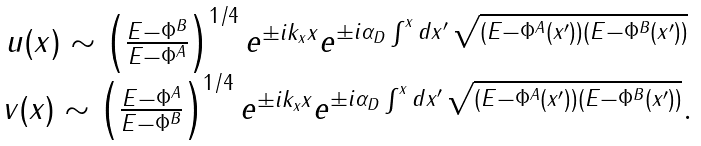<formula> <loc_0><loc_0><loc_500><loc_500>\begin{array} { c } u ( x ) \sim \left ( \frac { E - \Phi ^ { B } } { E - \Phi ^ { A } } \right ) ^ { 1 / 4 } e ^ { \pm i k _ { x } x } e ^ { \pm i \alpha _ { D } \int ^ { x } d x ^ { \prime } \, \sqrt { ( E - \Phi ^ { A } ( x ^ { \prime } ) ) ( E - \Phi ^ { B } ( x ^ { \prime } ) ) } } \\ v ( x ) \sim \left ( \frac { E - \Phi ^ { A } } { E - \Phi ^ { B } } \right ) ^ { 1 / 4 } e ^ { \pm i k _ { x } x } e ^ { \pm i \alpha _ { D } \int ^ { x } d x ^ { \prime } \, \sqrt { ( E - \Phi ^ { A } ( x ^ { \prime } ) ) ( E - \Phi ^ { B } ( x ^ { \prime } ) ) } } . \end{array}</formula> 